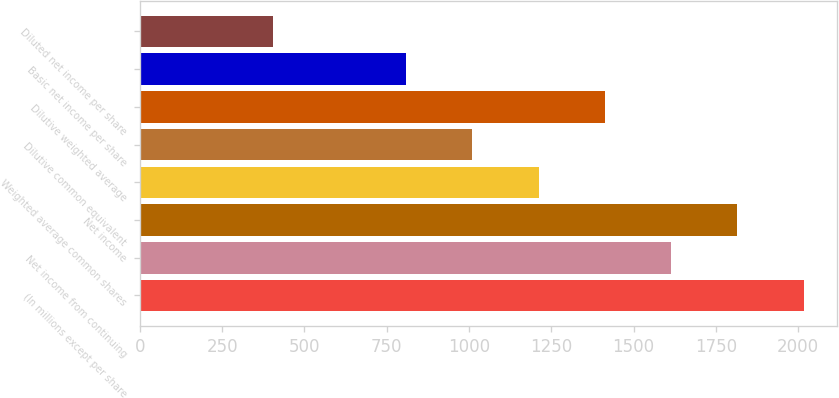Convert chart to OTSL. <chart><loc_0><loc_0><loc_500><loc_500><bar_chart><fcel>(In millions except per share<fcel>Net income from continuing<fcel>Net income<fcel>Weighted average common shares<fcel>Dilutive common equivalent<fcel>Dilutive weighted average<fcel>Basic net income per share<fcel>Diluted net income per share<nl><fcel>2017<fcel>1614.2<fcel>1815.6<fcel>1211.4<fcel>1010<fcel>1412.8<fcel>808.6<fcel>405.8<nl></chart> 